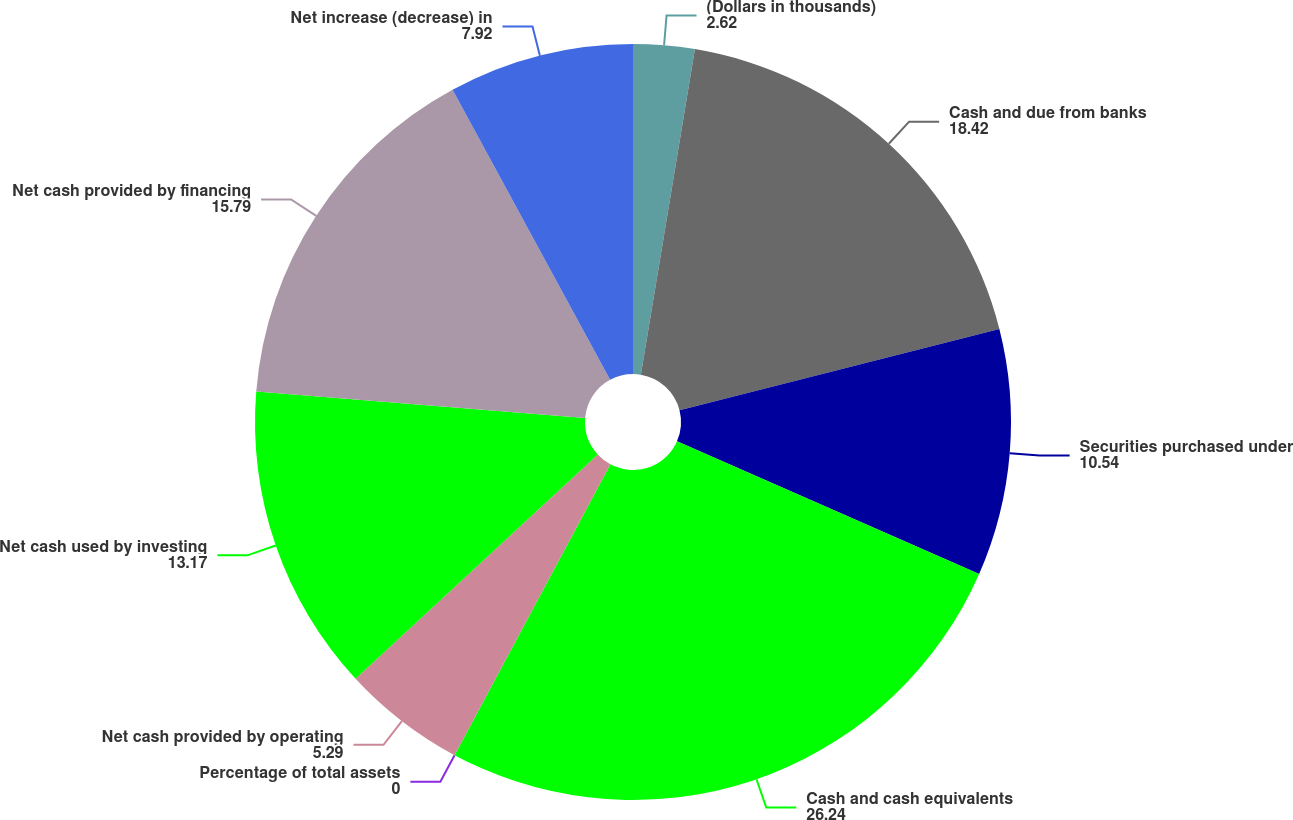Convert chart to OTSL. <chart><loc_0><loc_0><loc_500><loc_500><pie_chart><fcel>(Dollars in thousands)<fcel>Cash and due from banks<fcel>Securities purchased under<fcel>Cash and cash equivalents<fcel>Percentage of total assets<fcel>Net cash provided by operating<fcel>Net cash used by investing<fcel>Net cash provided by financing<fcel>Net increase (decrease) in<nl><fcel>2.62%<fcel>18.42%<fcel>10.54%<fcel>26.24%<fcel>0.0%<fcel>5.29%<fcel>13.17%<fcel>15.79%<fcel>7.92%<nl></chart> 